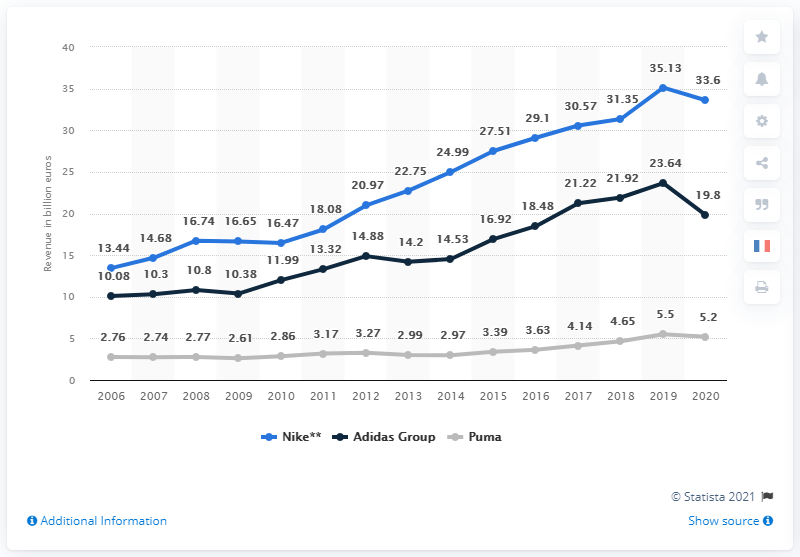Identify some key points in this picture. The global revenue of Adidas Group experienced a significant decline in a single year, reaching a decrease of 3.84%. In 2020, the Adidas Group generated 19.8 billion euros in revenue. The blue line reached its peak in the year 2019. 